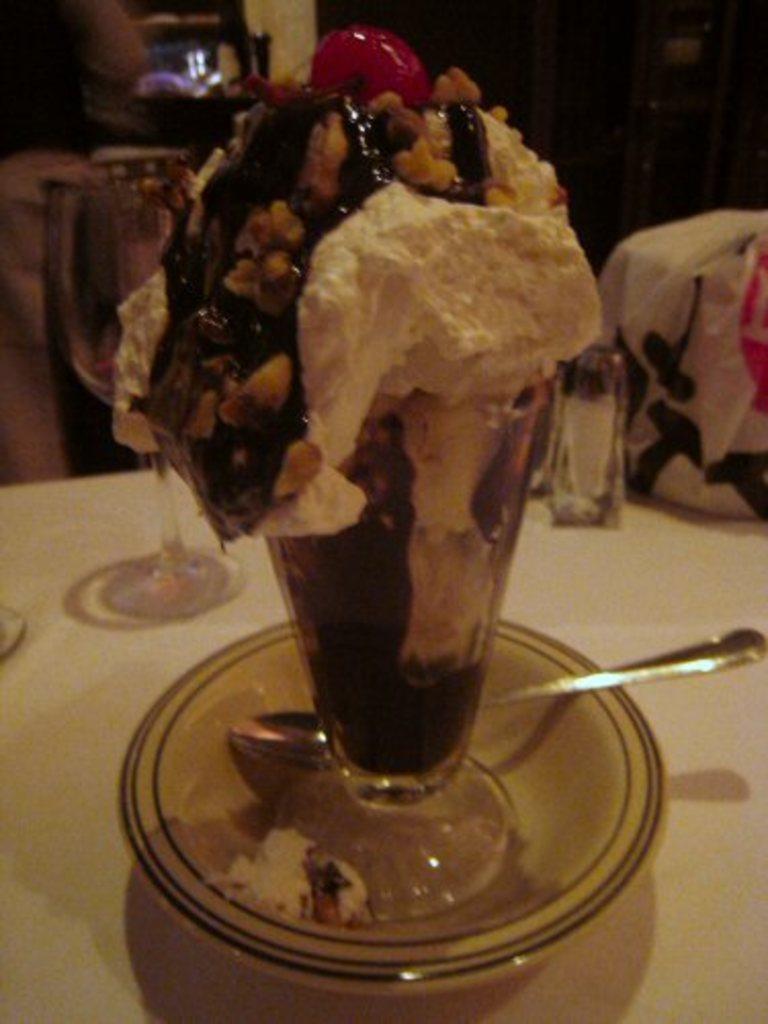In one or two sentences, can you explain what this image depicts? In the foreground of this image, there is an ice cream in a cup along with a spoon on a saucer on the table. Behind it, there is an object and glasses on the table and the background image is not clear. 